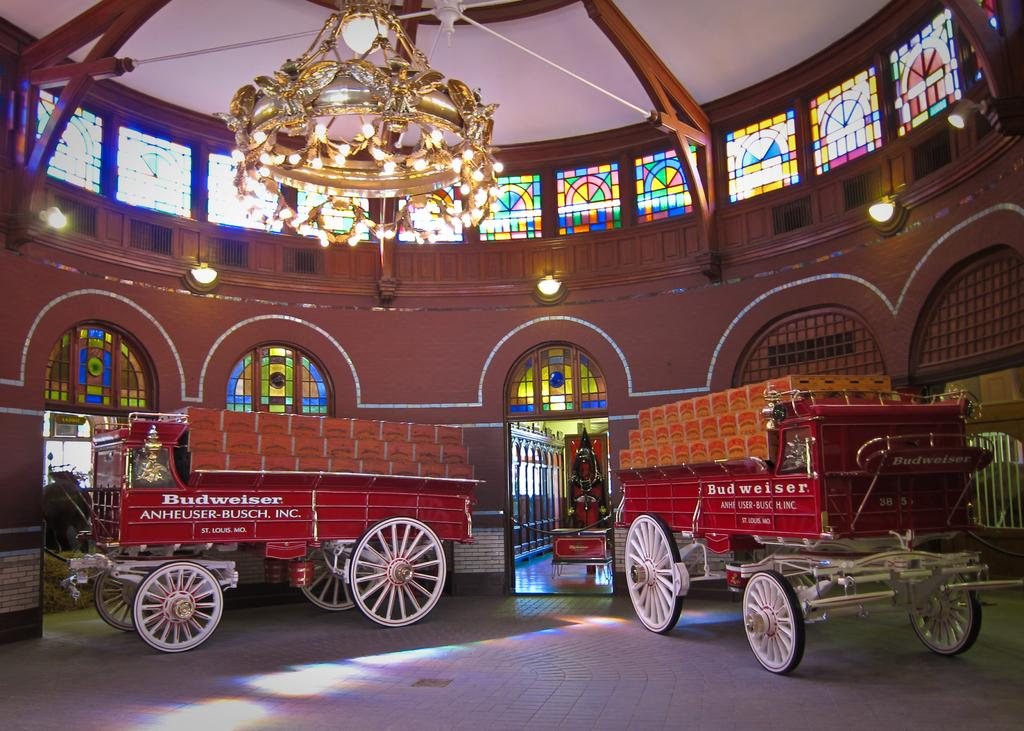What is the main object in the image? There is a cart in the image. What is inside the cart? The cart contains carton boxes. What type of surface is visible in the image? There is a floor visible in the image. What architectural feature can be seen in the image? There is an arch in the image. What type of lighting is present in the image? There are lights and a chandelier in the image. What can be seen through the windows in the image? There are windows in the image. Where is the cactus located in the image? There is no cactus present in the image. What story does the pipe tell in the image? There is no pipe present in the image, so it cannot tell a story. 